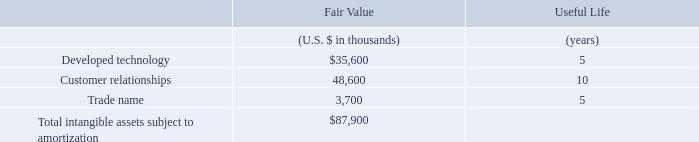The following table sets forth the components of identifiable intangible assets acquired and their estimated useful lives as of the date of acquisition.
The amount recorded for developed technology represents the estimated fair value of OpsGenie’s incident management and alerting technology. The amount recorded for customer relationships represents the fair value of the underlying relationships with OpsGenie customers. The amount recorded for trade name represents the fair value of OpsGenie trade name.
What does the amount recorded for developed technology represent? The estimated fair value of opsgenie’s incident management and alerting technology. What does the amount recorded for customer relationships represent? The fair value of the underlying relationships with opsgenie customers. What is the useful life for Developed technology? 5. What is the difference in useful life between developed technology and customer relationships? 10-5
Answer: 5. How many intangible assets have a useful life of more than 6 years? Customer relationships
Answer: 1. What is the percentage constitution of customer relationships among the total intangible assets subject to amortization?
Answer scale should be: percent. 48,600/87,900
Answer: 55.29. 